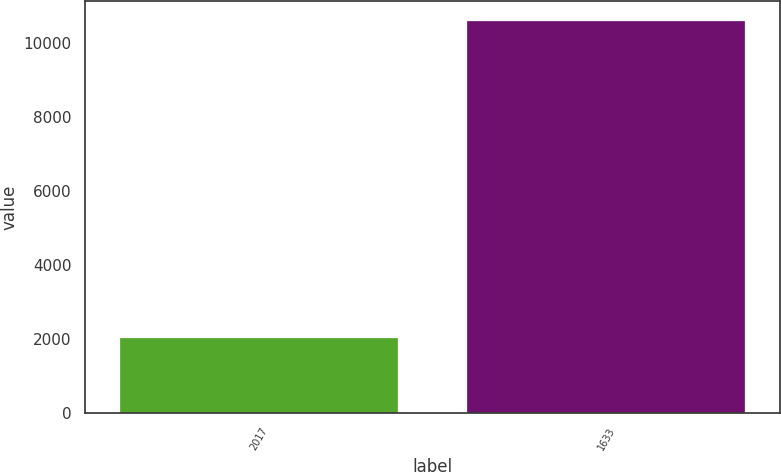Convert chart. <chart><loc_0><loc_0><loc_500><loc_500><bar_chart><fcel>2017<fcel>1633<nl><fcel>2016<fcel>10595<nl></chart> 